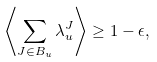Convert formula to latex. <formula><loc_0><loc_0><loc_500><loc_500>\left \langle \sum _ { J \in B _ { u } } \lambda _ { u } ^ { J } \right \rangle \geq 1 - \epsilon ,</formula> 